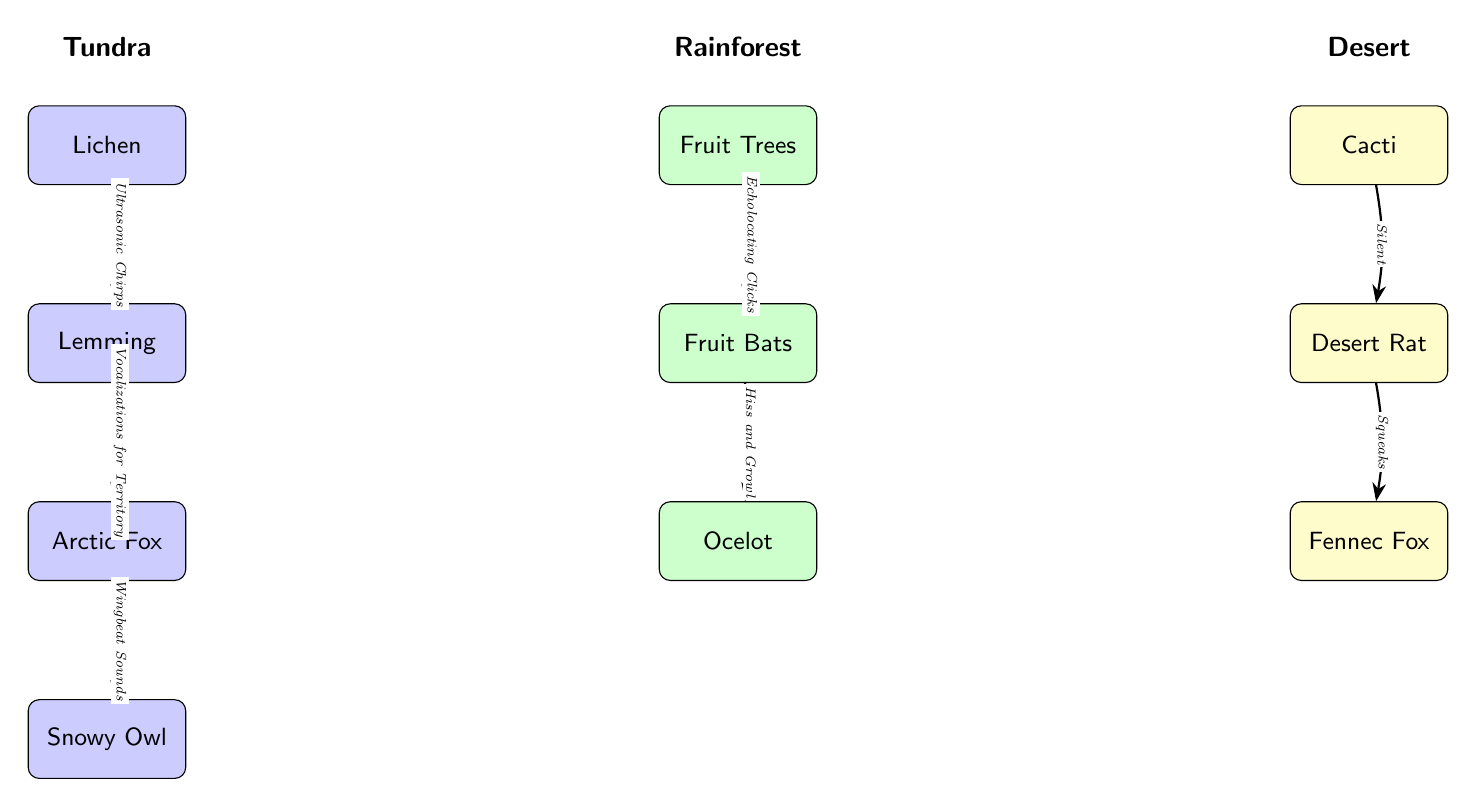What is the first organism in the tundra food chain? The diagram identifies 'Lichen' as the first organism in the tundra food chain, located at the top of the tundra section.
Answer: Lichen How many organisms are present in the rainforest chain? The rainforest chain includes three organisms: 'Fruit Trees', 'Fruit Bats', and 'Ocelot', which can be counted directly from the nodes in that section of the diagram.
Answer: 3 What type of sound does the Arctic Fox use for communication? According to the diagram, the Arctic Fox communicates using 'Vocalizations for Territory', which is stated on the edge connecting it to the lemming.
Answer: Vocalizations for Territory Which organism is at the bottom of the desert chain? The bottom-most organism in the desert chain is the 'Fennec Fox', as indicated in the diagram layout.
Answer: Fennec Fox In the rainforest chain, what communication method do Fruit Bats use? The method mentioned in the diagram for Fruit Bats is 'Echolocating Clicks', which connects them to the Fruit Trees.
Answer: Echolocating Clicks How many edges connect the tundra food chain? The tundra food chain contains three edges, connecting Lichen to Lemming, Lemming to Arctic Fox, and Arctic Fox to Snowy Owl, which can be counted from the connecting arrows in that section.
Answer: 3 What type of organism do cacti communicate with in the desert food chain? The diagram states that cacti communicate silently with the 'Desert Rat', as indicated by the edge connecting them with 'Silent' noted.
Answer: Desert Rat What is the relationship between the Ocelot and Fruit Bats in the rainforest? The diagram shows that the Ocelot has a relationship with the Fruit Bats through 'Hiss and Growl,' noted on the connecting edge from bats to ocelot.
Answer: Hiss and Growl What is the total number of food chains represented in the diagram? The diagram outlines three distinct food chains – tundra, rainforest, and desert – which can be identified by their individual sections.
Answer: 3 